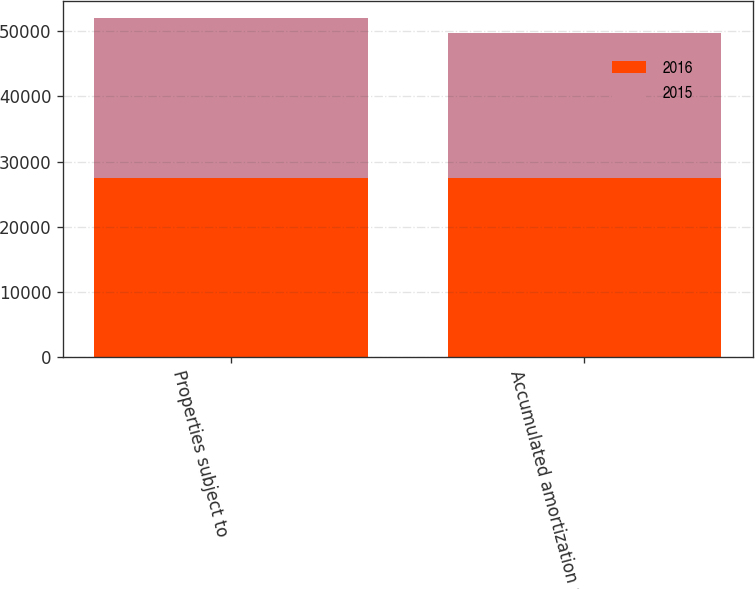Convert chart to OTSL. <chart><loc_0><loc_0><loc_500><loc_500><stacked_bar_chart><ecel><fcel>Properties subject to<fcel>Accumulated amortization a<nl><fcel>2016<fcel>27507<fcel>27433<nl><fcel>2015<fcel>24538<fcel>22276<nl></chart> 